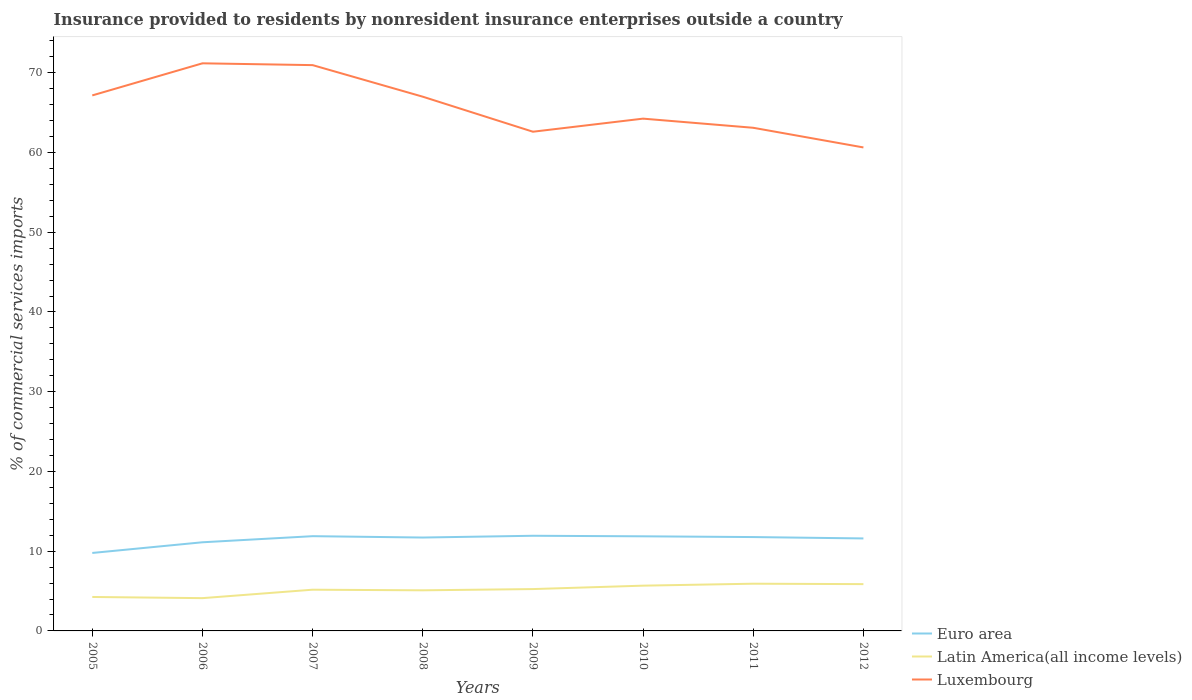Across all years, what is the maximum Insurance provided to residents in Luxembourg?
Provide a succinct answer. 60.64. In which year was the Insurance provided to residents in Euro area maximum?
Your answer should be very brief. 2005. What is the total Insurance provided to residents in Latin America(all income levels) in the graph?
Your response must be concise. -1.42. What is the difference between the highest and the second highest Insurance provided to residents in Luxembourg?
Keep it short and to the point. 10.55. How many lines are there?
Offer a very short reply. 3. Are the values on the major ticks of Y-axis written in scientific E-notation?
Your response must be concise. No. Does the graph contain grids?
Your answer should be compact. No. Where does the legend appear in the graph?
Your answer should be compact. Bottom right. How many legend labels are there?
Provide a short and direct response. 3. What is the title of the graph?
Provide a succinct answer. Insurance provided to residents by nonresident insurance enterprises outside a country. What is the label or title of the X-axis?
Your response must be concise. Years. What is the label or title of the Y-axis?
Provide a succinct answer. % of commercial services imports. What is the % of commercial services imports of Euro area in 2005?
Offer a very short reply. 9.78. What is the % of commercial services imports in Latin America(all income levels) in 2005?
Provide a succinct answer. 4.26. What is the % of commercial services imports in Luxembourg in 2005?
Ensure brevity in your answer.  67.16. What is the % of commercial services imports in Euro area in 2006?
Make the answer very short. 11.12. What is the % of commercial services imports in Latin America(all income levels) in 2006?
Offer a terse response. 4.11. What is the % of commercial services imports in Luxembourg in 2006?
Give a very brief answer. 71.19. What is the % of commercial services imports in Euro area in 2007?
Your response must be concise. 11.88. What is the % of commercial services imports of Latin America(all income levels) in 2007?
Offer a very short reply. 5.17. What is the % of commercial services imports in Luxembourg in 2007?
Your answer should be compact. 70.96. What is the % of commercial services imports in Euro area in 2008?
Ensure brevity in your answer.  11.71. What is the % of commercial services imports in Latin America(all income levels) in 2008?
Ensure brevity in your answer.  5.09. What is the % of commercial services imports of Luxembourg in 2008?
Your answer should be compact. 67. What is the % of commercial services imports of Euro area in 2009?
Your answer should be compact. 11.93. What is the % of commercial services imports of Latin America(all income levels) in 2009?
Your response must be concise. 5.25. What is the % of commercial services imports in Luxembourg in 2009?
Ensure brevity in your answer.  62.61. What is the % of commercial services imports of Euro area in 2010?
Provide a short and direct response. 11.87. What is the % of commercial services imports of Latin America(all income levels) in 2010?
Keep it short and to the point. 5.68. What is the % of commercial services imports in Luxembourg in 2010?
Ensure brevity in your answer.  64.25. What is the % of commercial services imports in Euro area in 2011?
Your response must be concise. 11.77. What is the % of commercial services imports in Latin America(all income levels) in 2011?
Ensure brevity in your answer.  5.92. What is the % of commercial services imports of Luxembourg in 2011?
Your answer should be very brief. 63.1. What is the % of commercial services imports in Euro area in 2012?
Ensure brevity in your answer.  11.6. What is the % of commercial services imports in Latin America(all income levels) in 2012?
Offer a terse response. 5.87. What is the % of commercial services imports of Luxembourg in 2012?
Offer a terse response. 60.64. Across all years, what is the maximum % of commercial services imports in Euro area?
Your response must be concise. 11.93. Across all years, what is the maximum % of commercial services imports in Latin America(all income levels)?
Your answer should be compact. 5.92. Across all years, what is the maximum % of commercial services imports in Luxembourg?
Keep it short and to the point. 71.19. Across all years, what is the minimum % of commercial services imports of Euro area?
Your response must be concise. 9.78. Across all years, what is the minimum % of commercial services imports of Latin America(all income levels)?
Your answer should be compact. 4.11. Across all years, what is the minimum % of commercial services imports of Luxembourg?
Your response must be concise. 60.64. What is the total % of commercial services imports of Euro area in the graph?
Your response must be concise. 91.66. What is the total % of commercial services imports in Latin America(all income levels) in the graph?
Your response must be concise. 41.35. What is the total % of commercial services imports of Luxembourg in the graph?
Your response must be concise. 526.89. What is the difference between the % of commercial services imports in Euro area in 2005 and that in 2006?
Ensure brevity in your answer.  -1.34. What is the difference between the % of commercial services imports of Latin America(all income levels) in 2005 and that in 2006?
Keep it short and to the point. 0.15. What is the difference between the % of commercial services imports of Luxembourg in 2005 and that in 2006?
Give a very brief answer. -4.03. What is the difference between the % of commercial services imports in Euro area in 2005 and that in 2007?
Keep it short and to the point. -2.1. What is the difference between the % of commercial services imports in Latin America(all income levels) in 2005 and that in 2007?
Offer a terse response. -0.91. What is the difference between the % of commercial services imports of Luxembourg in 2005 and that in 2007?
Your answer should be compact. -3.8. What is the difference between the % of commercial services imports in Euro area in 2005 and that in 2008?
Your answer should be very brief. -1.93. What is the difference between the % of commercial services imports in Latin America(all income levels) in 2005 and that in 2008?
Make the answer very short. -0.83. What is the difference between the % of commercial services imports of Luxembourg in 2005 and that in 2008?
Provide a succinct answer. 0.16. What is the difference between the % of commercial services imports in Euro area in 2005 and that in 2009?
Offer a very short reply. -2.16. What is the difference between the % of commercial services imports in Latin America(all income levels) in 2005 and that in 2009?
Your answer should be compact. -0.99. What is the difference between the % of commercial services imports in Luxembourg in 2005 and that in 2009?
Your response must be concise. 4.55. What is the difference between the % of commercial services imports in Euro area in 2005 and that in 2010?
Offer a terse response. -2.09. What is the difference between the % of commercial services imports of Latin America(all income levels) in 2005 and that in 2010?
Give a very brief answer. -1.42. What is the difference between the % of commercial services imports in Luxembourg in 2005 and that in 2010?
Your response must be concise. 2.91. What is the difference between the % of commercial services imports in Euro area in 2005 and that in 2011?
Offer a terse response. -1.99. What is the difference between the % of commercial services imports in Latin America(all income levels) in 2005 and that in 2011?
Your answer should be very brief. -1.66. What is the difference between the % of commercial services imports in Luxembourg in 2005 and that in 2011?
Offer a very short reply. 4.06. What is the difference between the % of commercial services imports in Euro area in 2005 and that in 2012?
Make the answer very short. -1.82. What is the difference between the % of commercial services imports in Latin America(all income levels) in 2005 and that in 2012?
Give a very brief answer. -1.61. What is the difference between the % of commercial services imports in Luxembourg in 2005 and that in 2012?
Offer a terse response. 6.52. What is the difference between the % of commercial services imports of Euro area in 2006 and that in 2007?
Provide a succinct answer. -0.76. What is the difference between the % of commercial services imports of Latin America(all income levels) in 2006 and that in 2007?
Provide a short and direct response. -1.06. What is the difference between the % of commercial services imports in Luxembourg in 2006 and that in 2007?
Make the answer very short. 0.23. What is the difference between the % of commercial services imports in Euro area in 2006 and that in 2008?
Your answer should be very brief. -0.59. What is the difference between the % of commercial services imports in Latin America(all income levels) in 2006 and that in 2008?
Make the answer very short. -0.98. What is the difference between the % of commercial services imports in Luxembourg in 2006 and that in 2008?
Ensure brevity in your answer.  4.19. What is the difference between the % of commercial services imports of Euro area in 2006 and that in 2009?
Provide a succinct answer. -0.82. What is the difference between the % of commercial services imports of Latin America(all income levels) in 2006 and that in 2009?
Keep it short and to the point. -1.14. What is the difference between the % of commercial services imports of Luxembourg in 2006 and that in 2009?
Ensure brevity in your answer.  8.58. What is the difference between the % of commercial services imports in Euro area in 2006 and that in 2010?
Your answer should be very brief. -0.75. What is the difference between the % of commercial services imports in Latin America(all income levels) in 2006 and that in 2010?
Give a very brief answer. -1.57. What is the difference between the % of commercial services imports in Luxembourg in 2006 and that in 2010?
Offer a very short reply. 6.94. What is the difference between the % of commercial services imports of Euro area in 2006 and that in 2011?
Offer a terse response. -0.65. What is the difference between the % of commercial services imports of Latin America(all income levels) in 2006 and that in 2011?
Make the answer very short. -1.81. What is the difference between the % of commercial services imports in Luxembourg in 2006 and that in 2011?
Provide a short and direct response. 8.08. What is the difference between the % of commercial services imports of Euro area in 2006 and that in 2012?
Your response must be concise. -0.48. What is the difference between the % of commercial services imports in Latin America(all income levels) in 2006 and that in 2012?
Provide a succinct answer. -1.76. What is the difference between the % of commercial services imports in Luxembourg in 2006 and that in 2012?
Offer a terse response. 10.55. What is the difference between the % of commercial services imports of Euro area in 2007 and that in 2008?
Provide a succinct answer. 0.17. What is the difference between the % of commercial services imports in Latin America(all income levels) in 2007 and that in 2008?
Your response must be concise. 0.08. What is the difference between the % of commercial services imports in Luxembourg in 2007 and that in 2008?
Keep it short and to the point. 3.96. What is the difference between the % of commercial services imports of Euro area in 2007 and that in 2009?
Make the answer very short. -0.05. What is the difference between the % of commercial services imports in Latin America(all income levels) in 2007 and that in 2009?
Provide a short and direct response. -0.08. What is the difference between the % of commercial services imports in Luxembourg in 2007 and that in 2009?
Provide a succinct answer. 8.35. What is the difference between the % of commercial services imports of Euro area in 2007 and that in 2010?
Your response must be concise. 0.02. What is the difference between the % of commercial services imports in Latin America(all income levels) in 2007 and that in 2010?
Your answer should be compact. -0.51. What is the difference between the % of commercial services imports of Luxembourg in 2007 and that in 2010?
Your answer should be very brief. 6.71. What is the difference between the % of commercial services imports in Euro area in 2007 and that in 2011?
Ensure brevity in your answer.  0.11. What is the difference between the % of commercial services imports in Latin America(all income levels) in 2007 and that in 2011?
Offer a terse response. -0.75. What is the difference between the % of commercial services imports of Luxembourg in 2007 and that in 2011?
Provide a short and direct response. 7.86. What is the difference between the % of commercial services imports of Euro area in 2007 and that in 2012?
Give a very brief answer. 0.28. What is the difference between the % of commercial services imports of Latin America(all income levels) in 2007 and that in 2012?
Your answer should be very brief. -0.7. What is the difference between the % of commercial services imports of Luxembourg in 2007 and that in 2012?
Make the answer very short. 10.32. What is the difference between the % of commercial services imports of Euro area in 2008 and that in 2009?
Offer a terse response. -0.22. What is the difference between the % of commercial services imports of Latin America(all income levels) in 2008 and that in 2009?
Your response must be concise. -0.16. What is the difference between the % of commercial services imports of Luxembourg in 2008 and that in 2009?
Your response must be concise. 4.39. What is the difference between the % of commercial services imports in Euro area in 2008 and that in 2010?
Your answer should be compact. -0.15. What is the difference between the % of commercial services imports in Latin America(all income levels) in 2008 and that in 2010?
Your answer should be compact. -0.59. What is the difference between the % of commercial services imports in Luxembourg in 2008 and that in 2010?
Give a very brief answer. 2.75. What is the difference between the % of commercial services imports of Euro area in 2008 and that in 2011?
Make the answer very short. -0.06. What is the difference between the % of commercial services imports of Latin America(all income levels) in 2008 and that in 2011?
Offer a terse response. -0.83. What is the difference between the % of commercial services imports in Luxembourg in 2008 and that in 2011?
Your answer should be very brief. 3.9. What is the difference between the % of commercial services imports in Euro area in 2008 and that in 2012?
Make the answer very short. 0.11. What is the difference between the % of commercial services imports in Latin America(all income levels) in 2008 and that in 2012?
Make the answer very short. -0.78. What is the difference between the % of commercial services imports in Luxembourg in 2008 and that in 2012?
Your answer should be compact. 6.36. What is the difference between the % of commercial services imports in Euro area in 2009 and that in 2010?
Make the answer very short. 0.07. What is the difference between the % of commercial services imports in Latin America(all income levels) in 2009 and that in 2010?
Your answer should be compact. -0.43. What is the difference between the % of commercial services imports of Luxembourg in 2009 and that in 2010?
Offer a very short reply. -1.64. What is the difference between the % of commercial services imports of Euro area in 2009 and that in 2011?
Your answer should be very brief. 0.16. What is the difference between the % of commercial services imports in Latin America(all income levels) in 2009 and that in 2011?
Make the answer very short. -0.67. What is the difference between the % of commercial services imports in Luxembourg in 2009 and that in 2011?
Offer a terse response. -0.49. What is the difference between the % of commercial services imports of Euro area in 2009 and that in 2012?
Keep it short and to the point. 0.33. What is the difference between the % of commercial services imports of Latin America(all income levels) in 2009 and that in 2012?
Keep it short and to the point. -0.62. What is the difference between the % of commercial services imports of Luxembourg in 2009 and that in 2012?
Your response must be concise. 1.97. What is the difference between the % of commercial services imports of Euro area in 2010 and that in 2011?
Your response must be concise. 0.09. What is the difference between the % of commercial services imports in Latin America(all income levels) in 2010 and that in 2011?
Offer a very short reply. -0.24. What is the difference between the % of commercial services imports in Luxembourg in 2010 and that in 2011?
Provide a short and direct response. 1.15. What is the difference between the % of commercial services imports of Euro area in 2010 and that in 2012?
Offer a very short reply. 0.27. What is the difference between the % of commercial services imports of Latin America(all income levels) in 2010 and that in 2012?
Provide a short and direct response. -0.19. What is the difference between the % of commercial services imports of Luxembourg in 2010 and that in 2012?
Offer a terse response. 3.61. What is the difference between the % of commercial services imports in Euro area in 2011 and that in 2012?
Provide a succinct answer. 0.17. What is the difference between the % of commercial services imports of Latin America(all income levels) in 2011 and that in 2012?
Your answer should be very brief. 0.05. What is the difference between the % of commercial services imports of Luxembourg in 2011 and that in 2012?
Give a very brief answer. 2.47. What is the difference between the % of commercial services imports in Euro area in 2005 and the % of commercial services imports in Latin America(all income levels) in 2006?
Provide a succinct answer. 5.67. What is the difference between the % of commercial services imports of Euro area in 2005 and the % of commercial services imports of Luxembourg in 2006?
Provide a succinct answer. -61.41. What is the difference between the % of commercial services imports in Latin America(all income levels) in 2005 and the % of commercial services imports in Luxembourg in 2006?
Your answer should be compact. -66.93. What is the difference between the % of commercial services imports of Euro area in 2005 and the % of commercial services imports of Latin America(all income levels) in 2007?
Your answer should be very brief. 4.61. What is the difference between the % of commercial services imports in Euro area in 2005 and the % of commercial services imports in Luxembourg in 2007?
Offer a very short reply. -61.18. What is the difference between the % of commercial services imports in Latin America(all income levels) in 2005 and the % of commercial services imports in Luxembourg in 2007?
Keep it short and to the point. -66.7. What is the difference between the % of commercial services imports of Euro area in 2005 and the % of commercial services imports of Latin America(all income levels) in 2008?
Offer a terse response. 4.69. What is the difference between the % of commercial services imports in Euro area in 2005 and the % of commercial services imports in Luxembourg in 2008?
Keep it short and to the point. -57.22. What is the difference between the % of commercial services imports in Latin America(all income levels) in 2005 and the % of commercial services imports in Luxembourg in 2008?
Ensure brevity in your answer.  -62.74. What is the difference between the % of commercial services imports of Euro area in 2005 and the % of commercial services imports of Latin America(all income levels) in 2009?
Offer a very short reply. 4.53. What is the difference between the % of commercial services imports in Euro area in 2005 and the % of commercial services imports in Luxembourg in 2009?
Provide a succinct answer. -52.83. What is the difference between the % of commercial services imports of Latin America(all income levels) in 2005 and the % of commercial services imports of Luxembourg in 2009?
Keep it short and to the point. -58.35. What is the difference between the % of commercial services imports in Euro area in 2005 and the % of commercial services imports in Latin America(all income levels) in 2010?
Keep it short and to the point. 4.1. What is the difference between the % of commercial services imports of Euro area in 2005 and the % of commercial services imports of Luxembourg in 2010?
Offer a very short reply. -54.47. What is the difference between the % of commercial services imports in Latin America(all income levels) in 2005 and the % of commercial services imports in Luxembourg in 2010?
Give a very brief answer. -59.99. What is the difference between the % of commercial services imports of Euro area in 2005 and the % of commercial services imports of Latin America(all income levels) in 2011?
Keep it short and to the point. 3.86. What is the difference between the % of commercial services imports of Euro area in 2005 and the % of commercial services imports of Luxembourg in 2011?
Keep it short and to the point. -53.32. What is the difference between the % of commercial services imports of Latin America(all income levels) in 2005 and the % of commercial services imports of Luxembourg in 2011?
Your answer should be very brief. -58.84. What is the difference between the % of commercial services imports of Euro area in 2005 and the % of commercial services imports of Latin America(all income levels) in 2012?
Provide a short and direct response. 3.91. What is the difference between the % of commercial services imports of Euro area in 2005 and the % of commercial services imports of Luxembourg in 2012?
Provide a succinct answer. -50.86. What is the difference between the % of commercial services imports in Latin America(all income levels) in 2005 and the % of commercial services imports in Luxembourg in 2012?
Your answer should be very brief. -56.38. What is the difference between the % of commercial services imports of Euro area in 2006 and the % of commercial services imports of Latin America(all income levels) in 2007?
Offer a very short reply. 5.95. What is the difference between the % of commercial services imports in Euro area in 2006 and the % of commercial services imports in Luxembourg in 2007?
Your response must be concise. -59.84. What is the difference between the % of commercial services imports of Latin America(all income levels) in 2006 and the % of commercial services imports of Luxembourg in 2007?
Offer a terse response. -66.85. What is the difference between the % of commercial services imports of Euro area in 2006 and the % of commercial services imports of Latin America(all income levels) in 2008?
Provide a short and direct response. 6.03. What is the difference between the % of commercial services imports in Euro area in 2006 and the % of commercial services imports in Luxembourg in 2008?
Keep it short and to the point. -55.88. What is the difference between the % of commercial services imports of Latin America(all income levels) in 2006 and the % of commercial services imports of Luxembourg in 2008?
Your answer should be very brief. -62.89. What is the difference between the % of commercial services imports in Euro area in 2006 and the % of commercial services imports in Latin America(all income levels) in 2009?
Provide a succinct answer. 5.87. What is the difference between the % of commercial services imports of Euro area in 2006 and the % of commercial services imports of Luxembourg in 2009?
Provide a succinct answer. -51.49. What is the difference between the % of commercial services imports in Latin America(all income levels) in 2006 and the % of commercial services imports in Luxembourg in 2009?
Provide a succinct answer. -58.5. What is the difference between the % of commercial services imports of Euro area in 2006 and the % of commercial services imports of Latin America(all income levels) in 2010?
Make the answer very short. 5.44. What is the difference between the % of commercial services imports of Euro area in 2006 and the % of commercial services imports of Luxembourg in 2010?
Offer a terse response. -53.13. What is the difference between the % of commercial services imports in Latin America(all income levels) in 2006 and the % of commercial services imports in Luxembourg in 2010?
Offer a terse response. -60.14. What is the difference between the % of commercial services imports in Euro area in 2006 and the % of commercial services imports in Latin America(all income levels) in 2011?
Give a very brief answer. 5.2. What is the difference between the % of commercial services imports in Euro area in 2006 and the % of commercial services imports in Luxembourg in 2011?
Ensure brevity in your answer.  -51.98. What is the difference between the % of commercial services imports in Latin America(all income levels) in 2006 and the % of commercial services imports in Luxembourg in 2011?
Make the answer very short. -58.99. What is the difference between the % of commercial services imports of Euro area in 2006 and the % of commercial services imports of Latin America(all income levels) in 2012?
Give a very brief answer. 5.25. What is the difference between the % of commercial services imports of Euro area in 2006 and the % of commercial services imports of Luxembourg in 2012?
Provide a succinct answer. -49.52. What is the difference between the % of commercial services imports in Latin America(all income levels) in 2006 and the % of commercial services imports in Luxembourg in 2012?
Your answer should be compact. -56.53. What is the difference between the % of commercial services imports of Euro area in 2007 and the % of commercial services imports of Latin America(all income levels) in 2008?
Offer a very short reply. 6.79. What is the difference between the % of commercial services imports in Euro area in 2007 and the % of commercial services imports in Luxembourg in 2008?
Provide a short and direct response. -55.12. What is the difference between the % of commercial services imports of Latin America(all income levels) in 2007 and the % of commercial services imports of Luxembourg in 2008?
Ensure brevity in your answer.  -61.83. What is the difference between the % of commercial services imports of Euro area in 2007 and the % of commercial services imports of Latin America(all income levels) in 2009?
Make the answer very short. 6.63. What is the difference between the % of commercial services imports in Euro area in 2007 and the % of commercial services imports in Luxembourg in 2009?
Your answer should be compact. -50.72. What is the difference between the % of commercial services imports of Latin America(all income levels) in 2007 and the % of commercial services imports of Luxembourg in 2009?
Your answer should be very brief. -57.44. What is the difference between the % of commercial services imports in Euro area in 2007 and the % of commercial services imports in Latin America(all income levels) in 2010?
Make the answer very short. 6.2. What is the difference between the % of commercial services imports in Euro area in 2007 and the % of commercial services imports in Luxembourg in 2010?
Ensure brevity in your answer.  -52.37. What is the difference between the % of commercial services imports of Latin America(all income levels) in 2007 and the % of commercial services imports of Luxembourg in 2010?
Give a very brief answer. -59.08. What is the difference between the % of commercial services imports in Euro area in 2007 and the % of commercial services imports in Latin America(all income levels) in 2011?
Offer a very short reply. 5.96. What is the difference between the % of commercial services imports of Euro area in 2007 and the % of commercial services imports of Luxembourg in 2011?
Provide a succinct answer. -51.22. What is the difference between the % of commercial services imports in Latin America(all income levels) in 2007 and the % of commercial services imports in Luxembourg in 2011?
Offer a terse response. -57.93. What is the difference between the % of commercial services imports in Euro area in 2007 and the % of commercial services imports in Latin America(all income levels) in 2012?
Your answer should be compact. 6.01. What is the difference between the % of commercial services imports of Euro area in 2007 and the % of commercial services imports of Luxembourg in 2012?
Your answer should be very brief. -48.75. What is the difference between the % of commercial services imports in Latin America(all income levels) in 2007 and the % of commercial services imports in Luxembourg in 2012?
Give a very brief answer. -55.47. What is the difference between the % of commercial services imports of Euro area in 2008 and the % of commercial services imports of Latin America(all income levels) in 2009?
Provide a succinct answer. 6.46. What is the difference between the % of commercial services imports of Euro area in 2008 and the % of commercial services imports of Luxembourg in 2009?
Offer a terse response. -50.89. What is the difference between the % of commercial services imports of Latin America(all income levels) in 2008 and the % of commercial services imports of Luxembourg in 2009?
Provide a short and direct response. -57.51. What is the difference between the % of commercial services imports in Euro area in 2008 and the % of commercial services imports in Latin America(all income levels) in 2010?
Make the answer very short. 6.03. What is the difference between the % of commercial services imports of Euro area in 2008 and the % of commercial services imports of Luxembourg in 2010?
Offer a terse response. -52.54. What is the difference between the % of commercial services imports of Latin America(all income levels) in 2008 and the % of commercial services imports of Luxembourg in 2010?
Your answer should be compact. -59.16. What is the difference between the % of commercial services imports in Euro area in 2008 and the % of commercial services imports in Latin America(all income levels) in 2011?
Your answer should be very brief. 5.79. What is the difference between the % of commercial services imports in Euro area in 2008 and the % of commercial services imports in Luxembourg in 2011?
Provide a short and direct response. -51.39. What is the difference between the % of commercial services imports of Latin America(all income levels) in 2008 and the % of commercial services imports of Luxembourg in 2011?
Your response must be concise. -58.01. What is the difference between the % of commercial services imports of Euro area in 2008 and the % of commercial services imports of Latin America(all income levels) in 2012?
Provide a short and direct response. 5.84. What is the difference between the % of commercial services imports of Euro area in 2008 and the % of commercial services imports of Luxembourg in 2012?
Your answer should be compact. -48.92. What is the difference between the % of commercial services imports of Latin America(all income levels) in 2008 and the % of commercial services imports of Luxembourg in 2012?
Provide a succinct answer. -55.54. What is the difference between the % of commercial services imports of Euro area in 2009 and the % of commercial services imports of Latin America(all income levels) in 2010?
Give a very brief answer. 6.26. What is the difference between the % of commercial services imports of Euro area in 2009 and the % of commercial services imports of Luxembourg in 2010?
Provide a succinct answer. -52.31. What is the difference between the % of commercial services imports of Latin America(all income levels) in 2009 and the % of commercial services imports of Luxembourg in 2010?
Your response must be concise. -59. What is the difference between the % of commercial services imports in Euro area in 2009 and the % of commercial services imports in Latin America(all income levels) in 2011?
Keep it short and to the point. 6.01. What is the difference between the % of commercial services imports of Euro area in 2009 and the % of commercial services imports of Luxembourg in 2011?
Offer a terse response. -51.17. What is the difference between the % of commercial services imports of Latin America(all income levels) in 2009 and the % of commercial services imports of Luxembourg in 2011?
Keep it short and to the point. -57.85. What is the difference between the % of commercial services imports of Euro area in 2009 and the % of commercial services imports of Latin America(all income levels) in 2012?
Give a very brief answer. 6.07. What is the difference between the % of commercial services imports in Euro area in 2009 and the % of commercial services imports in Luxembourg in 2012?
Your response must be concise. -48.7. What is the difference between the % of commercial services imports of Latin America(all income levels) in 2009 and the % of commercial services imports of Luxembourg in 2012?
Give a very brief answer. -55.39. What is the difference between the % of commercial services imports of Euro area in 2010 and the % of commercial services imports of Latin America(all income levels) in 2011?
Give a very brief answer. 5.94. What is the difference between the % of commercial services imports of Euro area in 2010 and the % of commercial services imports of Luxembourg in 2011?
Your response must be concise. -51.23. What is the difference between the % of commercial services imports in Latin America(all income levels) in 2010 and the % of commercial services imports in Luxembourg in 2011?
Offer a very short reply. -57.42. What is the difference between the % of commercial services imports of Euro area in 2010 and the % of commercial services imports of Latin America(all income levels) in 2012?
Give a very brief answer. 6. What is the difference between the % of commercial services imports in Euro area in 2010 and the % of commercial services imports in Luxembourg in 2012?
Your response must be concise. -48.77. What is the difference between the % of commercial services imports in Latin America(all income levels) in 2010 and the % of commercial services imports in Luxembourg in 2012?
Make the answer very short. -54.96. What is the difference between the % of commercial services imports in Euro area in 2011 and the % of commercial services imports in Latin America(all income levels) in 2012?
Offer a terse response. 5.9. What is the difference between the % of commercial services imports of Euro area in 2011 and the % of commercial services imports of Luxembourg in 2012?
Give a very brief answer. -48.86. What is the difference between the % of commercial services imports of Latin America(all income levels) in 2011 and the % of commercial services imports of Luxembourg in 2012?
Your answer should be very brief. -54.71. What is the average % of commercial services imports of Euro area per year?
Offer a very short reply. 11.46. What is the average % of commercial services imports in Latin America(all income levels) per year?
Provide a short and direct response. 5.17. What is the average % of commercial services imports of Luxembourg per year?
Offer a terse response. 65.86. In the year 2005, what is the difference between the % of commercial services imports of Euro area and % of commercial services imports of Latin America(all income levels)?
Your answer should be compact. 5.52. In the year 2005, what is the difference between the % of commercial services imports in Euro area and % of commercial services imports in Luxembourg?
Give a very brief answer. -57.38. In the year 2005, what is the difference between the % of commercial services imports in Latin America(all income levels) and % of commercial services imports in Luxembourg?
Provide a succinct answer. -62.9. In the year 2006, what is the difference between the % of commercial services imports of Euro area and % of commercial services imports of Latin America(all income levels)?
Ensure brevity in your answer.  7.01. In the year 2006, what is the difference between the % of commercial services imports in Euro area and % of commercial services imports in Luxembourg?
Keep it short and to the point. -60.07. In the year 2006, what is the difference between the % of commercial services imports in Latin America(all income levels) and % of commercial services imports in Luxembourg?
Give a very brief answer. -67.07. In the year 2007, what is the difference between the % of commercial services imports of Euro area and % of commercial services imports of Latin America(all income levels)?
Provide a short and direct response. 6.71. In the year 2007, what is the difference between the % of commercial services imports in Euro area and % of commercial services imports in Luxembourg?
Your response must be concise. -59.08. In the year 2007, what is the difference between the % of commercial services imports of Latin America(all income levels) and % of commercial services imports of Luxembourg?
Provide a short and direct response. -65.79. In the year 2008, what is the difference between the % of commercial services imports in Euro area and % of commercial services imports in Latin America(all income levels)?
Give a very brief answer. 6.62. In the year 2008, what is the difference between the % of commercial services imports of Euro area and % of commercial services imports of Luxembourg?
Your answer should be compact. -55.29. In the year 2008, what is the difference between the % of commercial services imports in Latin America(all income levels) and % of commercial services imports in Luxembourg?
Make the answer very short. -61.91. In the year 2009, what is the difference between the % of commercial services imports in Euro area and % of commercial services imports in Latin America(all income levels)?
Provide a succinct answer. 6.68. In the year 2009, what is the difference between the % of commercial services imports of Euro area and % of commercial services imports of Luxembourg?
Your answer should be compact. -50.67. In the year 2009, what is the difference between the % of commercial services imports in Latin America(all income levels) and % of commercial services imports in Luxembourg?
Provide a succinct answer. -57.36. In the year 2010, what is the difference between the % of commercial services imports in Euro area and % of commercial services imports in Latin America(all income levels)?
Your response must be concise. 6.19. In the year 2010, what is the difference between the % of commercial services imports in Euro area and % of commercial services imports in Luxembourg?
Your answer should be very brief. -52.38. In the year 2010, what is the difference between the % of commercial services imports of Latin America(all income levels) and % of commercial services imports of Luxembourg?
Your answer should be very brief. -58.57. In the year 2011, what is the difference between the % of commercial services imports in Euro area and % of commercial services imports in Latin America(all income levels)?
Provide a succinct answer. 5.85. In the year 2011, what is the difference between the % of commercial services imports of Euro area and % of commercial services imports of Luxembourg?
Offer a terse response. -51.33. In the year 2011, what is the difference between the % of commercial services imports of Latin America(all income levels) and % of commercial services imports of Luxembourg?
Your response must be concise. -57.18. In the year 2012, what is the difference between the % of commercial services imports of Euro area and % of commercial services imports of Latin America(all income levels)?
Your response must be concise. 5.73. In the year 2012, what is the difference between the % of commercial services imports in Euro area and % of commercial services imports in Luxembourg?
Your answer should be compact. -49.04. In the year 2012, what is the difference between the % of commercial services imports in Latin America(all income levels) and % of commercial services imports in Luxembourg?
Provide a short and direct response. -54.77. What is the ratio of the % of commercial services imports of Euro area in 2005 to that in 2006?
Provide a succinct answer. 0.88. What is the ratio of the % of commercial services imports of Latin America(all income levels) in 2005 to that in 2006?
Your answer should be compact. 1.04. What is the ratio of the % of commercial services imports in Luxembourg in 2005 to that in 2006?
Offer a very short reply. 0.94. What is the ratio of the % of commercial services imports of Euro area in 2005 to that in 2007?
Your answer should be very brief. 0.82. What is the ratio of the % of commercial services imports of Latin America(all income levels) in 2005 to that in 2007?
Give a very brief answer. 0.82. What is the ratio of the % of commercial services imports in Luxembourg in 2005 to that in 2007?
Offer a very short reply. 0.95. What is the ratio of the % of commercial services imports in Euro area in 2005 to that in 2008?
Provide a short and direct response. 0.83. What is the ratio of the % of commercial services imports in Latin America(all income levels) in 2005 to that in 2008?
Your answer should be very brief. 0.84. What is the ratio of the % of commercial services imports of Luxembourg in 2005 to that in 2008?
Give a very brief answer. 1. What is the ratio of the % of commercial services imports of Euro area in 2005 to that in 2009?
Provide a succinct answer. 0.82. What is the ratio of the % of commercial services imports in Latin America(all income levels) in 2005 to that in 2009?
Keep it short and to the point. 0.81. What is the ratio of the % of commercial services imports of Luxembourg in 2005 to that in 2009?
Offer a terse response. 1.07. What is the ratio of the % of commercial services imports of Euro area in 2005 to that in 2010?
Keep it short and to the point. 0.82. What is the ratio of the % of commercial services imports in Latin America(all income levels) in 2005 to that in 2010?
Make the answer very short. 0.75. What is the ratio of the % of commercial services imports of Luxembourg in 2005 to that in 2010?
Make the answer very short. 1.05. What is the ratio of the % of commercial services imports of Euro area in 2005 to that in 2011?
Offer a terse response. 0.83. What is the ratio of the % of commercial services imports of Latin America(all income levels) in 2005 to that in 2011?
Give a very brief answer. 0.72. What is the ratio of the % of commercial services imports of Luxembourg in 2005 to that in 2011?
Your response must be concise. 1.06. What is the ratio of the % of commercial services imports in Euro area in 2005 to that in 2012?
Provide a succinct answer. 0.84. What is the ratio of the % of commercial services imports of Latin America(all income levels) in 2005 to that in 2012?
Offer a terse response. 0.73. What is the ratio of the % of commercial services imports in Luxembourg in 2005 to that in 2012?
Provide a succinct answer. 1.11. What is the ratio of the % of commercial services imports of Euro area in 2006 to that in 2007?
Ensure brevity in your answer.  0.94. What is the ratio of the % of commercial services imports in Latin America(all income levels) in 2006 to that in 2007?
Your answer should be very brief. 0.8. What is the ratio of the % of commercial services imports in Euro area in 2006 to that in 2008?
Offer a very short reply. 0.95. What is the ratio of the % of commercial services imports of Latin America(all income levels) in 2006 to that in 2008?
Make the answer very short. 0.81. What is the ratio of the % of commercial services imports of Luxembourg in 2006 to that in 2008?
Your response must be concise. 1.06. What is the ratio of the % of commercial services imports of Euro area in 2006 to that in 2009?
Give a very brief answer. 0.93. What is the ratio of the % of commercial services imports of Latin America(all income levels) in 2006 to that in 2009?
Give a very brief answer. 0.78. What is the ratio of the % of commercial services imports in Luxembourg in 2006 to that in 2009?
Provide a short and direct response. 1.14. What is the ratio of the % of commercial services imports in Euro area in 2006 to that in 2010?
Offer a very short reply. 0.94. What is the ratio of the % of commercial services imports of Latin America(all income levels) in 2006 to that in 2010?
Offer a terse response. 0.72. What is the ratio of the % of commercial services imports in Luxembourg in 2006 to that in 2010?
Keep it short and to the point. 1.11. What is the ratio of the % of commercial services imports of Euro area in 2006 to that in 2011?
Ensure brevity in your answer.  0.94. What is the ratio of the % of commercial services imports in Latin America(all income levels) in 2006 to that in 2011?
Keep it short and to the point. 0.69. What is the ratio of the % of commercial services imports in Luxembourg in 2006 to that in 2011?
Your answer should be very brief. 1.13. What is the ratio of the % of commercial services imports in Euro area in 2006 to that in 2012?
Offer a terse response. 0.96. What is the ratio of the % of commercial services imports of Latin America(all income levels) in 2006 to that in 2012?
Provide a short and direct response. 0.7. What is the ratio of the % of commercial services imports of Luxembourg in 2006 to that in 2012?
Keep it short and to the point. 1.17. What is the ratio of the % of commercial services imports in Euro area in 2007 to that in 2008?
Provide a succinct answer. 1.01. What is the ratio of the % of commercial services imports of Latin America(all income levels) in 2007 to that in 2008?
Provide a succinct answer. 1.02. What is the ratio of the % of commercial services imports in Luxembourg in 2007 to that in 2008?
Give a very brief answer. 1.06. What is the ratio of the % of commercial services imports of Latin America(all income levels) in 2007 to that in 2009?
Ensure brevity in your answer.  0.99. What is the ratio of the % of commercial services imports of Luxembourg in 2007 to that in 2009?
Keep it short and to the point. 1.13. What is the ratio of the % of commercial services imports in Latin America(all income levels) in 2007 to that in 2010?
Provide a short and direct response. 0.91. What is the ratio of the % of commercial services imports in Luxembourg in 2007 to that in 2010?
Your response must be concise. 1.1. What is the ratio of the % of commercial services imports in Euro area in 2007 to that in 2011?
Provide a succinct answer. 1.01. What is the ratio of the % of commercial services imports of Latin America(all income levels) in 2007 to that in 2011?
Your answer should be very brief. 0.87. What is the ratio of the % of commercial services imports in Luxembourg in 2007 to that in 2011?
Provide a succinct answer. 1.12. What is the ratio of the % of commercial services imports in Euro area in 2007 to that in 2012?
Provide a succinct answer. 1.02. What is the ratio of the % of commercial services imports of Latin America(all income levels) in 2007 to that in 2012?
Make the answer very short. 0.88. What is the ratio of the % of commercial services imports of Luxembourg in 2007 to that in 2012?
Give a very brief answer. 1.17. What is the ratio of the % of commercial services imports of Euro area in 2008 to that in 2009?
Your answer should be compact. 0.98. What is the ratio of the % of commercial services imports in Latin America(all income levels) in 2008 to that in 2009?
Your answer should be compact. 0.97. What is the ratio of the % of commercial services imports in Luxembourg in 2008 to that in 2009?
Provide a succinct answer. 1.07. What is the ratio of the % of commercial services imports in Latin America(all income levels) in 2008 to that in 2010?
Provide a short and direct response. 0.9. What is the ratio of the % of commercial services imports in Luxembourg in 2008 to that in 2010?
Keep it short and to the point. 1.04. What is the ratio of the % of commercial services imports in Latin America(all income levels) in 2008 to that in 2011?
Ensure brevity in your answer.  0.86. What is the ratio of the % of commercial services imports of Luxembourg in 2008 to that in 2011?
Your answer should be compact. 1.06. What is the ratio of the % of commercial services imports in Euro area in 2008 to that in 2012?
Your answer should be compact. 1.01. What is the ratio of the % of commercial services imports of Latin America(all income levels) in 2008 to that in 2012?
Give a very brief answer. 0.87. What is the ratio of the % of commercial services imports of Luxembourg in 2008 to that in 2012?
Make the answer very short. 1.1. What is the ratio of the % of commercial services imports in Latin America(all income levels) in 2009 to that in 2010?
Make the answer very short. 0.92. What is the ratio of the % of commercial services imports in Luxembourg in 2009 to that in 2010?
Offer a very short reply. 0.97. What is the ratio of the % of commercial services imports in Euro area in 2009 to that in 2011?
Offer a very short reply. 1.01. What is the ratio of the % of commercial services imports of Latin America(all income levels) in 2009 to that in 2011?
Your response must be concise. 0.89. What is the ratio of the % of commercial services imports in Euro area in 2009 to that in 2012?
Your response must be concise. 1.03. What is the ratio of the % of commercial services imports of Latin America(all income levels) in 2009 to that in 2012?
Ensure brevity in your answer.  0.89. What is the ratio of the % of commercial services imports in Luxembourg in 2009 to that in 2012?
Provide a short and direct response. 1.03. What is the ratio of the % of commercial services imports in Euro area in 2010 to that in 2011?
Provide a succinct answer. 1.01. What is the ratio of the % of commercial services imports in Latin America(all income levels) in 2010 to that in 2011?
Your answer should be very brief. 0.96. What is the ratio of the % of commercial services imports in Luxembourg in 2010 to that in 2011?
Make the answer very short. 1.02. What is the ratio of the % of commercial services imports in Euro area in 2010 to that in 2012?
Keep it short and to the point. 1.02. What is the ratio of the % of commercial services imports in Latin America(all income levels) in 2010 to that in 2012?
Provide a succinct answer. 0.97. What is the ratio of the % of commercial services imports of Luxembourg in 2010 to that in 2012?
Keep it short and to the point. 1.06. What is the ratio of the % of commercial services imports of Euro area in 2011 to that in 2012?
Provide a short and direct response. 1.01. What is the ratio of the % of commercial services imports in Latin America(all income levels) in 2011 to that in 2012?
Your answer should be compact. 1.01. What is the ratio of the % of commercial services imports in Luxembourg in 2011 to that in 2012?
Keep it short and to the point. 1.04. What is the difference between the highest and the second highest % of commercial services imports of Euro area?
Your answer should be compact. 0.05. What is the difference between the highest and the second highest % of commercial services imports in Latin America(all income levels)?
Provide a short and direct response. 0.05. What is the difference between the highest and the second highest % of commercial services imports in Luxembourg?
Make the answer very short. 0.23. What is the difference between the highest and the lowest % of commercial services imports of Euro area?
Give a very brief answer. 2.16. What is the difference between the highest and the lowest % of commercial services imports of Latin America(all income levels)?
Offer a terse response. 1.81. What is the difference between the highest and the lowest % of commercial services imports of Luxembourg?
Ensure brevity in your answer.  10.55. 